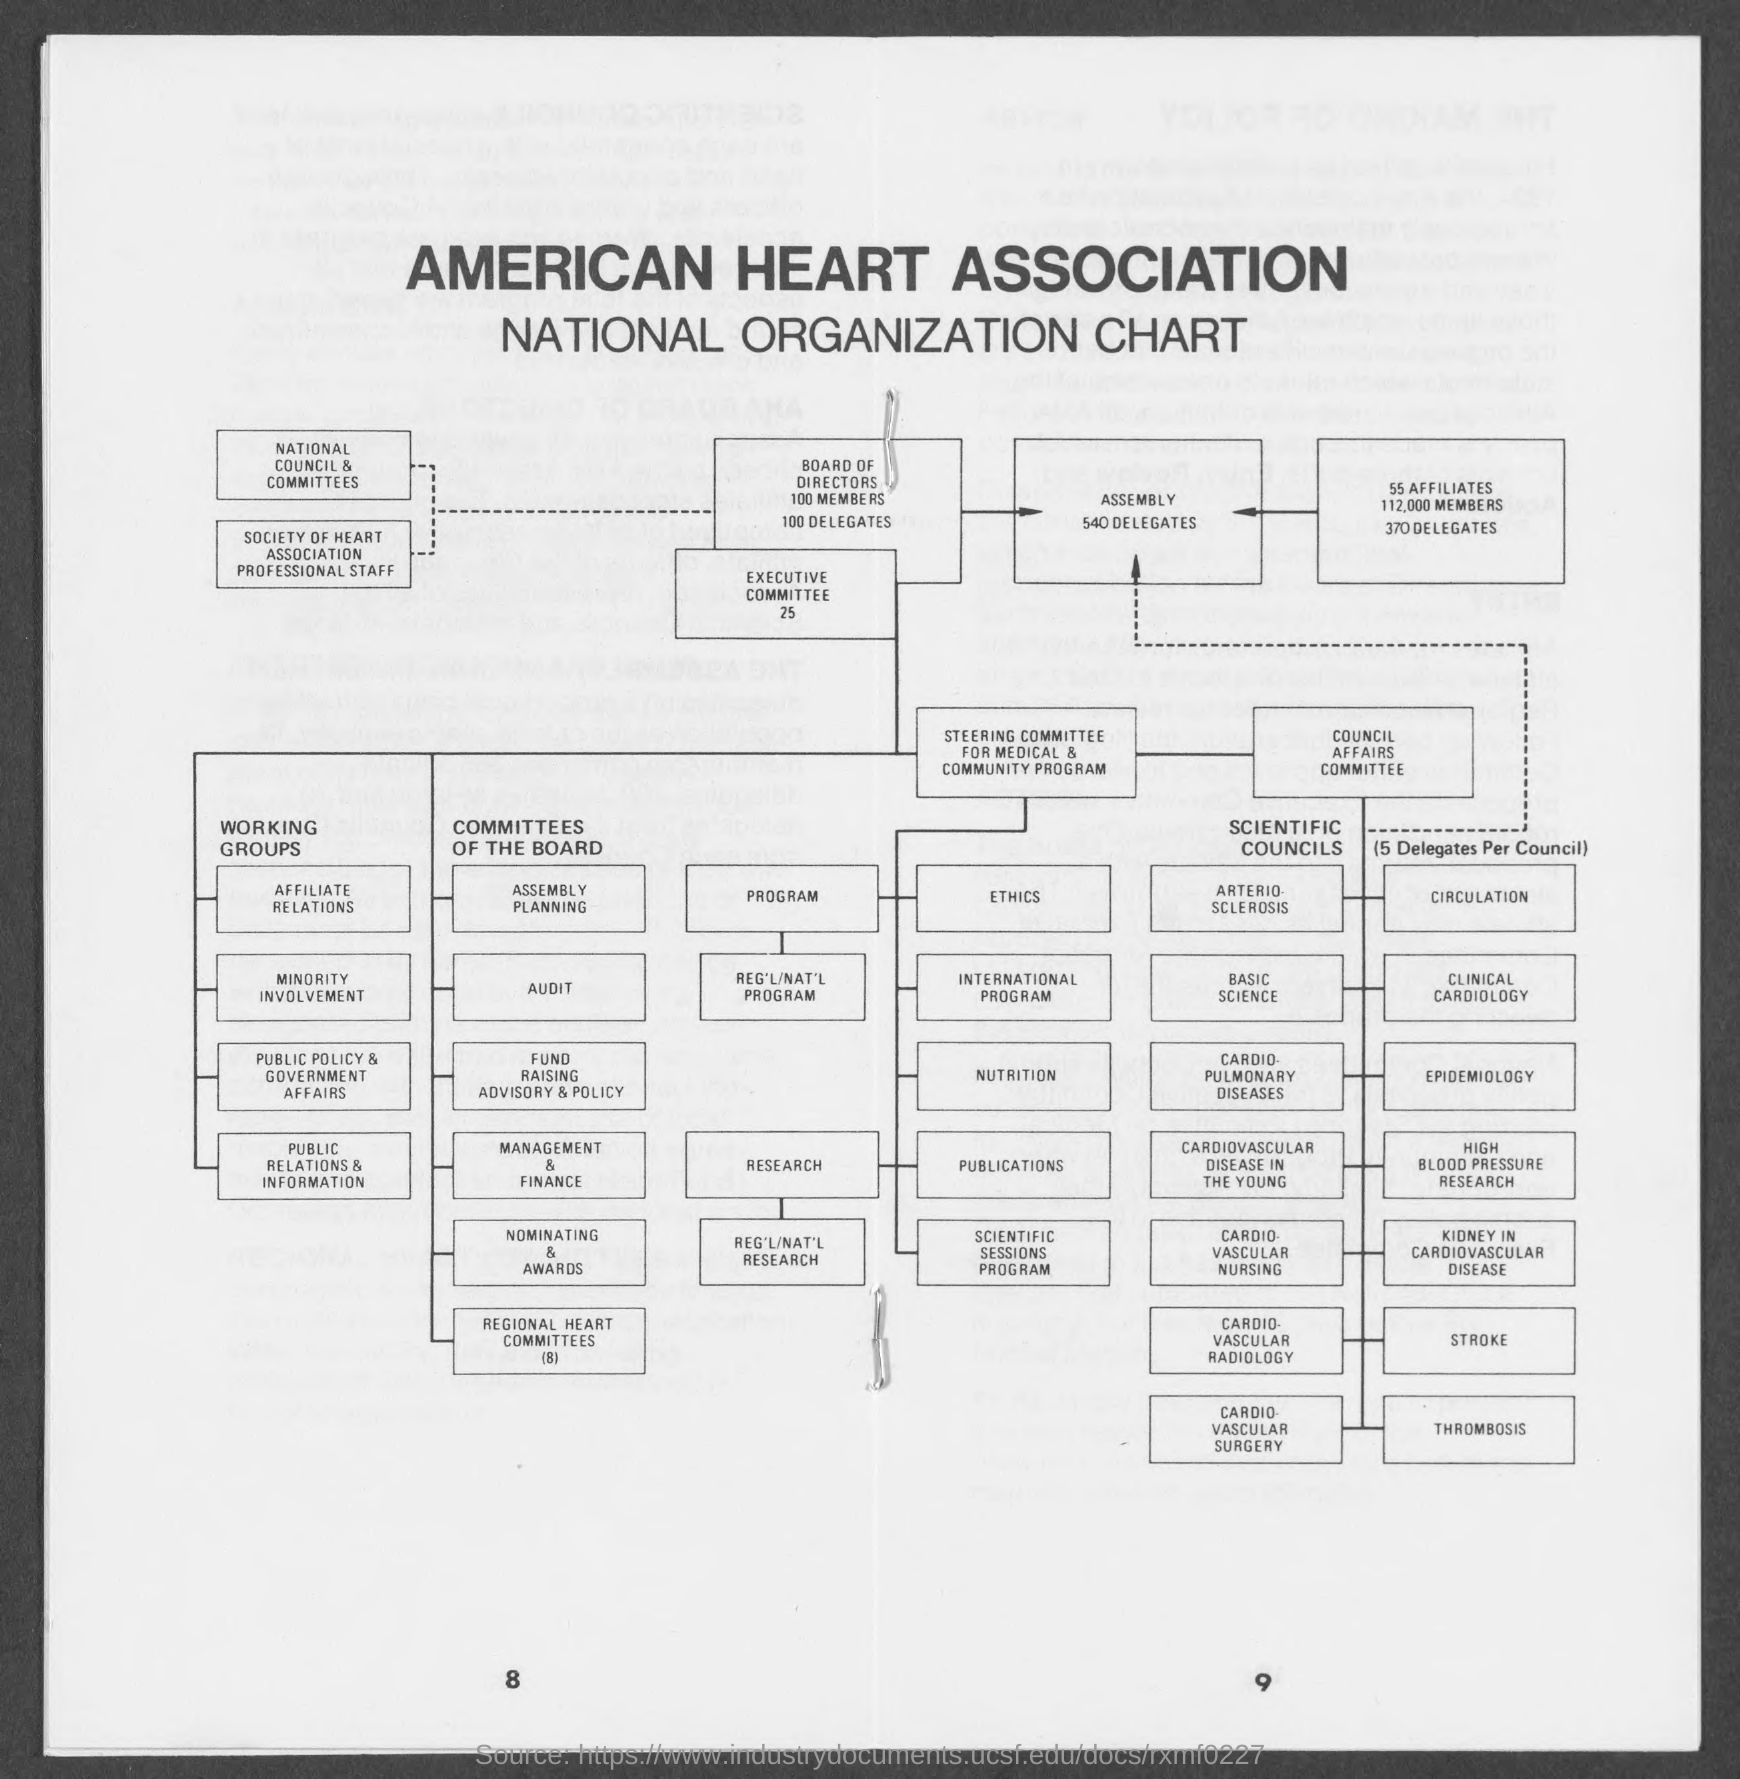Give some essential details in this illustration. The number at the bottom right of the page is 9. The number at the bottom left page is eight. 